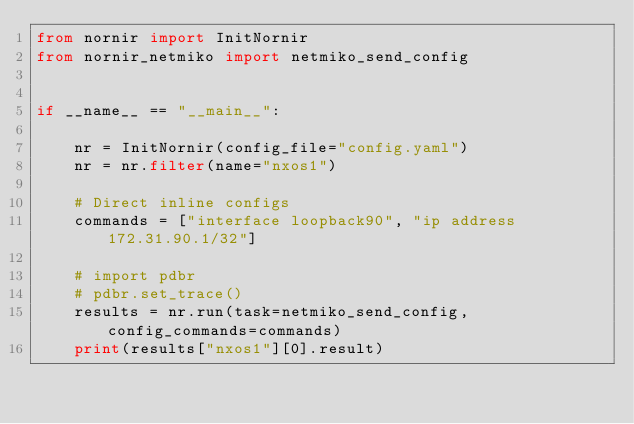Convert code to text. <code><loc_0><loc_0><loc_500><loc_500><_Python_>from nornir import InitNornir
from nornir_netmiko import netmiko_send_config


if __name__ == "__main__":

    nr = InitNornir(config_file="config.yaml")
    nr = nr.filter(name="nxos1")

    # Direct inline configs
    commands = ["interface loopback90", "ip address 172.31.90.1/32"]

    # import pdbr
    # pdbr.set_trace()
    results = nr.run(task=netmiko_send_config, config_commands=commands)
    print(results["nxos1"][0].result)
</code> 